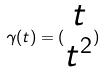Convert formula to latex. <formula><loc_0><loc_0><loc_500><loc_500>\gamma ( t ) = ( \begin{matrix} t \\ t ^ { 2 } \end{matrix} )</formula> 